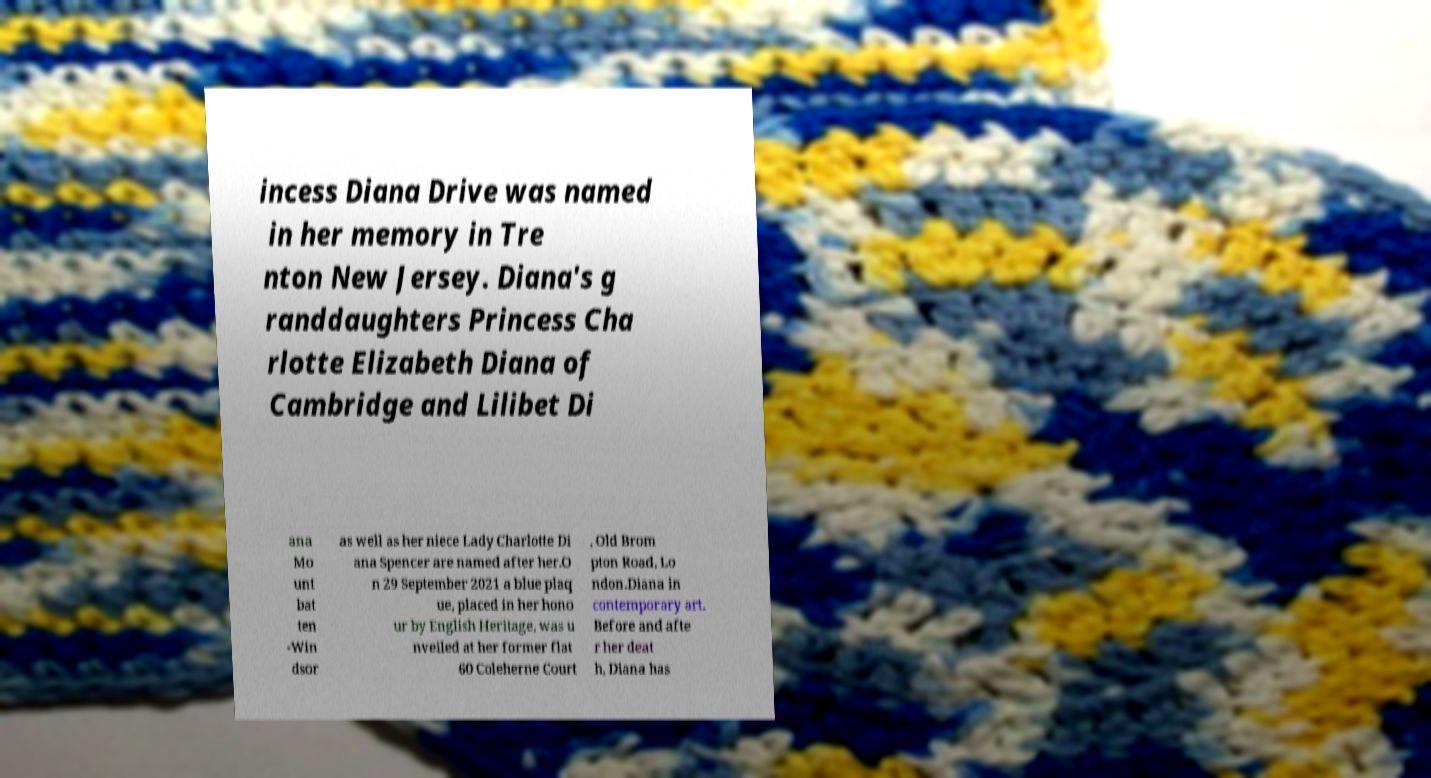What messages or text are displayed in this image? I need them in a readable, typed format. incess Diana Drive was named in her memory in Tre nton New Jersey. Diana's g randdaughters Princess Cha rlotte Elizabeth Diana of Cambridge and Lilibet Di ana Mo unt bat ten -Win dsor as well as her niece Lady Charlotte Di ana Spencer are named after her.O n 29 September 2021 a blue plaq ue, placed in her hono ur by English Heritage, was u nveiled at her former flat 60 Coleherne Court , Old Brom pton Road, Lo ndon.Diana in contemporary art. Before and afte r her deat h, Diana has 